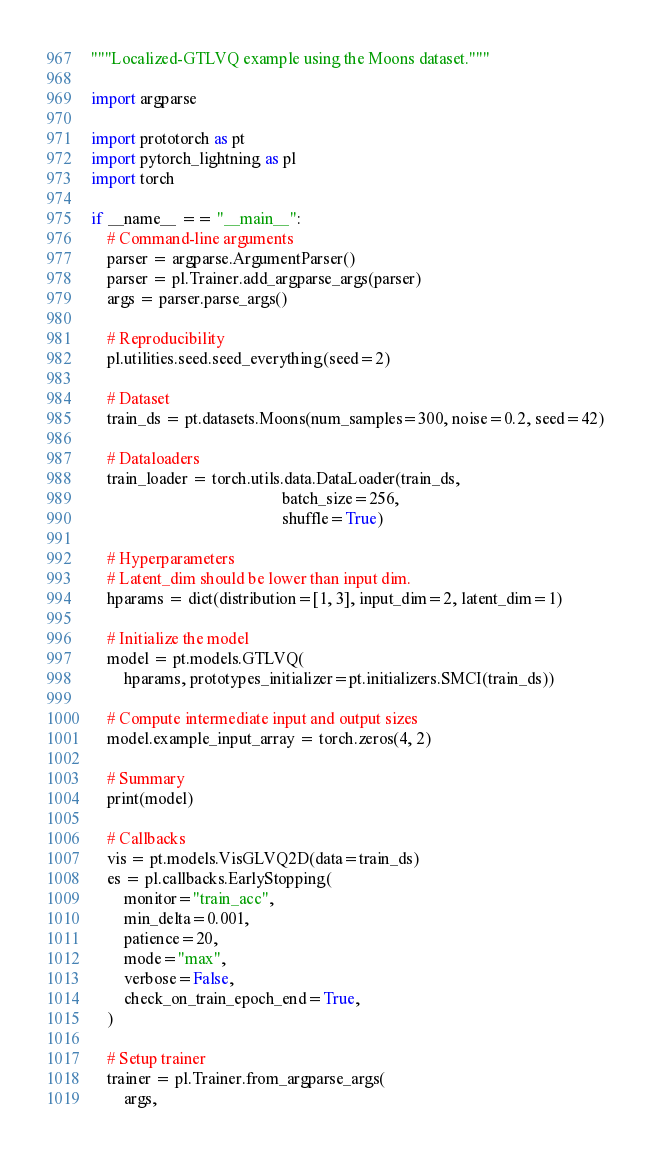<code> <loc_0><loc_0><loc_500><loc_500><_Python_>"""Localized-GTLVQ example using the Moons dataset."""

import argparse

import prototorch as pt
import pytorch_lightning as pl
import torch

if __name__ == "__main__":
    # Command-line arguments
    parser = argparse.ArgumentParser()
    parser = pl.Trainer.add_argparse_args(parser)
    args = parser.parse_args()

    # Reproducibility
    pl.utilities.seed.seed_everything(seed=2)

    # Dataset
    train_ds = pt.datasets.Moons(num_samples=300, noise=0.2, seed=42)

    # Dataloaders
    train_loader = torch.utils.data.DataLoader(train_ds,
                                               batch_size=256,
                                               shuffle=True)

    # Hyperparameters
    # Latent_dim should be lower than input dim.
    hparams = dict(distribution=[1, 3], input_dim=2, latent_dim=1)

    # Initialize the model
    model = pt.models.GTLVQ(
        hparams, prototypes_initializer=pt.initializers.SMCI(train_ds))

    # Compute intermediate input and output sizes
    model.example_input_array = torch.zeros(4, 2)

    # Summary
    print(model)

    # Callbacks
    vis = pt.models.VisGLVQ2D(data=train_ds)
    es = pl.callbacks.EarlyStopping(
        monitor="train_acc",
        min_delta=0.001,
        patience=20,
        mode="max",
        verbose=False,
        check_on_train_epoch_end=True,
    )

    # Setup trainer
    trainer = pl.Trainer.from_argparse_args(
        args,</code> 